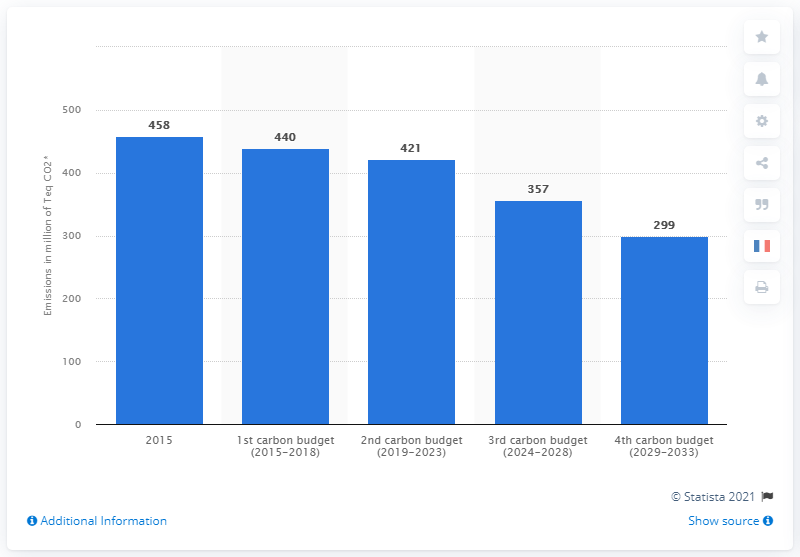Indicate a few pertinent items in this graphic. The carbon budget for France from 2029 to 2033 is 299. 